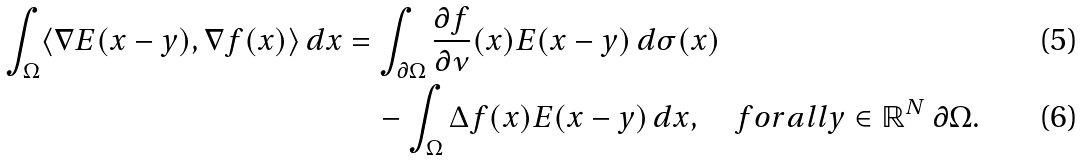Convert formula to latex. <formula><loc_0><loc_0><loc_500><loc_500>\int _ { \Omega } \langle \nabla E ( x - y ) , \nabla f ( x ) \rangle \, d x & = \int _ { \partial \Omega } \frac { \partial f } { \partial \nu } ( x ) E ( x - y ) \, d \sigma ( x ) \\ & \quad - \int _ { \Omega } \Delta f ( x ) E ( x - y ) \, d x , \quad f o r a l l y \in { \mathbb { R } } ^ { N } \ \partial \Omega .</formula> 